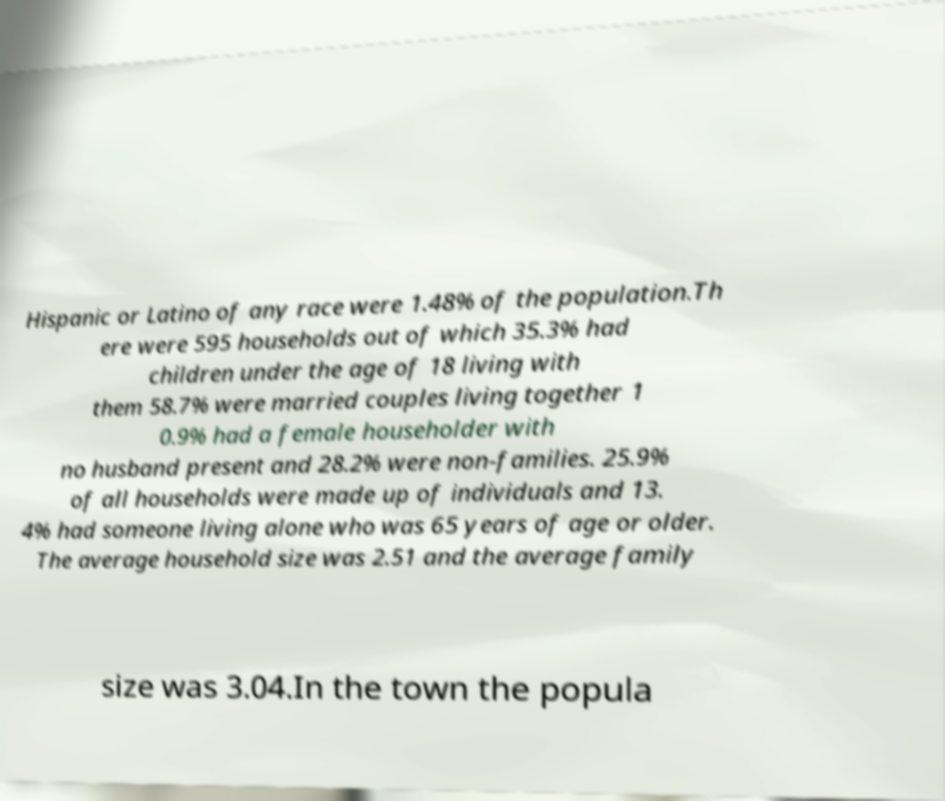Please identify and transcribe the text found in this image. Hispanic or Latino of any race were 1.48% of the population.Th ere were 595 households out of which 35.3% had children under the age of 18 living with them 58.7% were married couples living together 1 0.9% had a female householder with no husband present and 28.2% were non-families. 25.9% of all households were made up of individuals and 13. 4% had someone living alone who was 65 years of age or older. The average household size was 2.51 and the average family size was 3.04.In the town the popula 